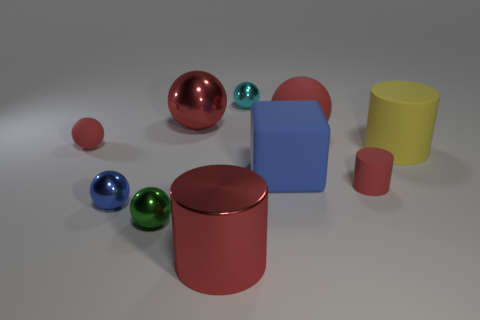How many red balls must be subtracted to get 1 red balls? 2 Subtract all large red metal cylinders. How many cylinders are left? 2 Subtract all green balls. How many balls are left? 5 Subtract all brown blocks. How many red cylinders are left? 2 Subtract all spheres. How many objects are left? 4 Subtract 2 cylinders. How many cylinders are left? 1 Subtract all big yellow matte spheres. Subtract all big matte cylinders. How many objects are left? 9 Add 2 blue rubber blocks. How many blue rubber blocks are left? 3 Add 2 tiny metallic spheres. How many tiny metallic spheres exist? 5 Subtract 0 purple blocks. How many objects are left? 10 